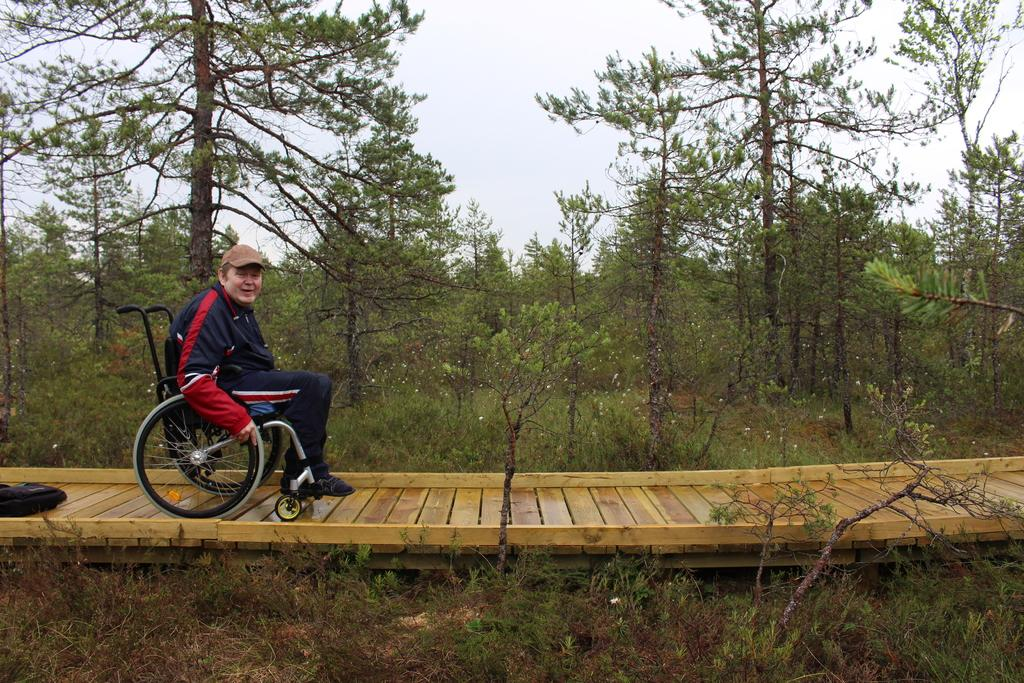What is the man in the image sitting on? The man is sitting on a wheelchair in the image. Where is the man located in the image? The man is on a platform in the image. What can be seen on the left side of the platform? There is a bag on the left side of the platform. What type of natural environment is visible in the background of the image? Trees, grass, and the sky are visible in the background of the image. What type of library can be seen in the background of the image? There is no library present in the image; the background features trees, grass, and the sky. 